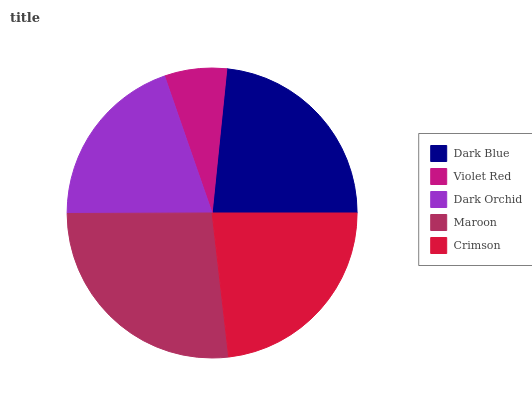Is Violet Red the minimum?
Answer yes or no. Yes. Is Maroon the maximum?
Answer yes or no. Yes. Is Dark Orchid the minimum?
Answer yes or no. No. Is Dark Orchid the maximum?
Answer yes or no. No. Is Dark Orchid greater than Violet Red?
Answer yes or no. Yes. Is Violet Red less than Dark Orchid?
Answer yes or no. Yes. Is Violet Red greater than Dark Orchid?
Answer yes or no. No. Is Dark Orchid less than Violet Red?
Answer yes or no. No. Is Crimson the high median?
Answer yes or no. Yes. Is Crimson the low median?
Answer yes or no. Yes. Is Maroon the high median?
Answer yes or no. No. Is Dark Orchid the low median?
Answer yes or no. No. 